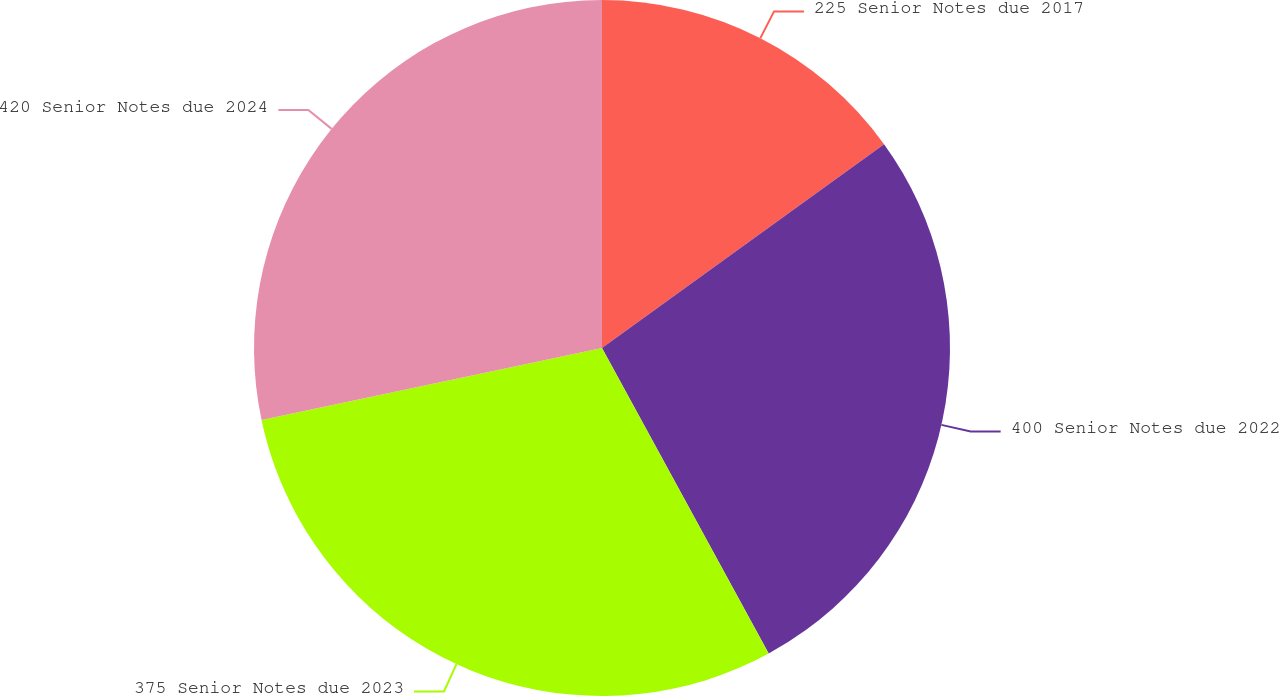Convert chart. <chart><loc_0><loc_0><loc_500><loc_500><pie_chart><fcel>225 Senior Notes due 2017<fcel>400 Senior Notes due 2022<fcel>375 Senior Notes due 2023<fcel>420 Senior Notes due 2024<nl><fcel>15.04%<fcel>27.01%<fcel>29.63%<fcel>28.32%<nl></chart> 